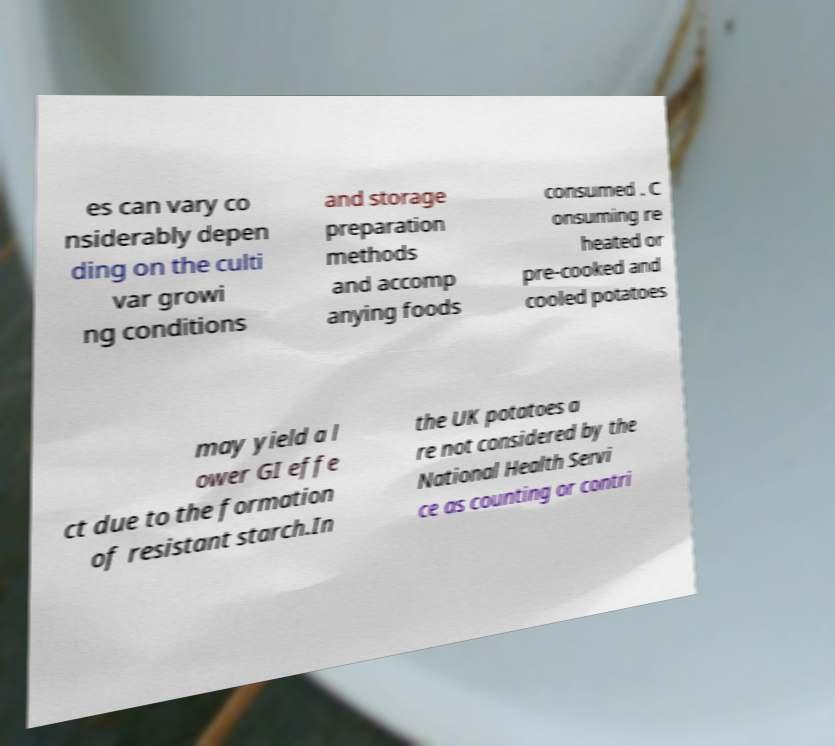Could you extract and type out the text from this image? es can vary co nsiderably depen ding on the culti var growi ng conditions and storage preparation methods and accomp anying foods consumed . C onsuming re heated or pre-cooked and cooled potatoes may yield a l ower GI effe ct due to the formation of resistant starch.In the UK potatoes a re not considered by the National Health Servi ce as counting or contri 